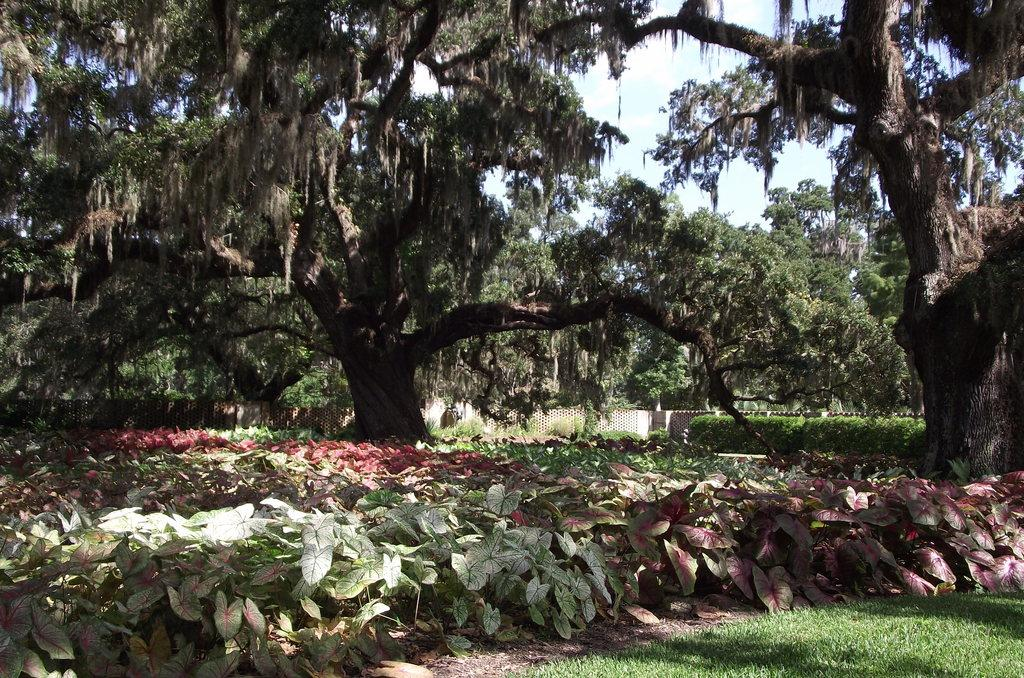What type of vegetation can be seen in the image? There is grass, small plants, shrubs, and trees in the image. What type of structure is present in the image? There is a wooden fence in the image. What can be seen in the background of the image? The sky is visible in the background of the image. How many hands are visible in the image? There are no hands visible in the image. What type of comfort can be found in the image? The image does not depict any objects or situations that would suggest comfort. 